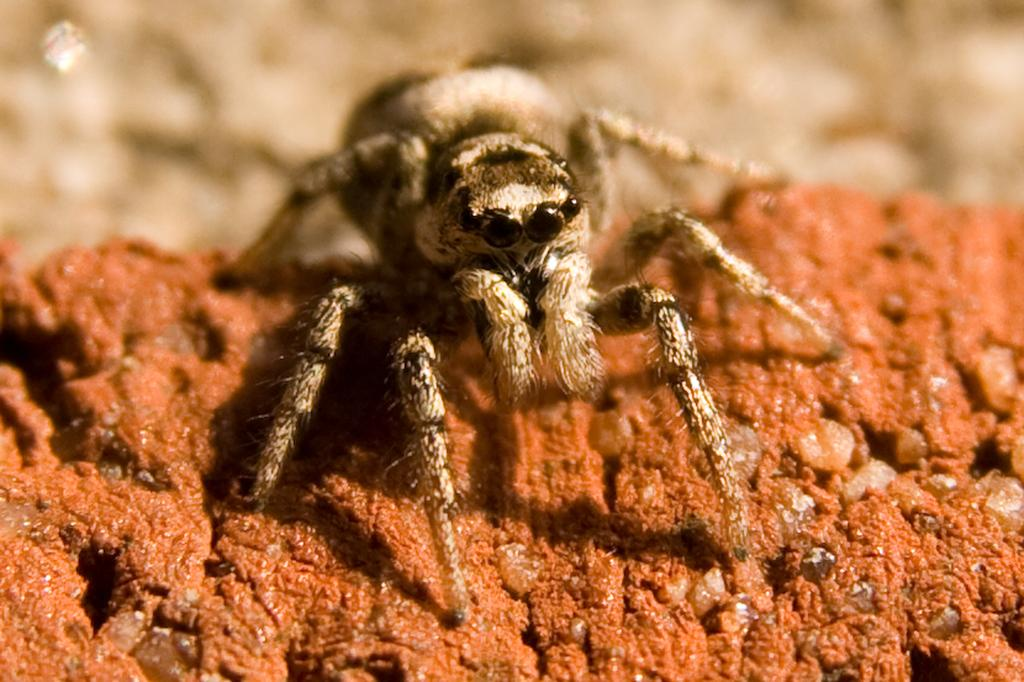What is the main subject of the picture? The main subject of the picture is a spider. What is the color of the surface the spider is on? The spider is on a brown color surface. Can you describe the top part of the image? The top of the image is blurred. What type of car can be seen in the background of the image? There is no car present in the image; it features a spider on a brown surface with a blurred top part. 